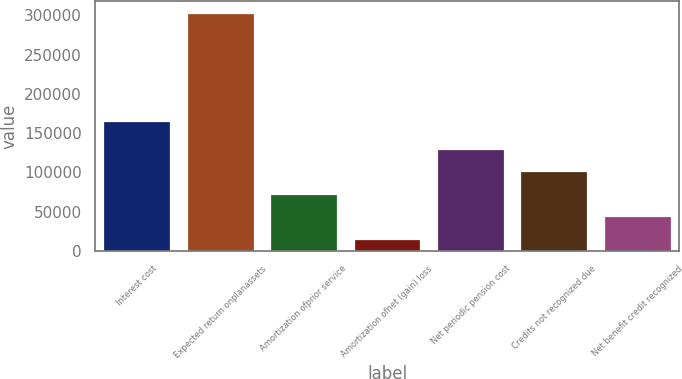Convert chart to OTSL. <chart><loc_0><loc_0><loc_500><loc_500><bar_chart><fcel>Interest cost<fcel>Expected return onplanassets<fcel>Amortization ofprior service<fcel>Amortization ofnet (gain) loss<fcel>Net periodic pension cost<fcel>Credits not recognized due<fcel>Net benefit credit recognized<nl><fcel>165361<fcel>302958<fcel>72757.2<fcel>15207<fcel>130307<fcel>101532<fcel>43982.1<nl></chart> 